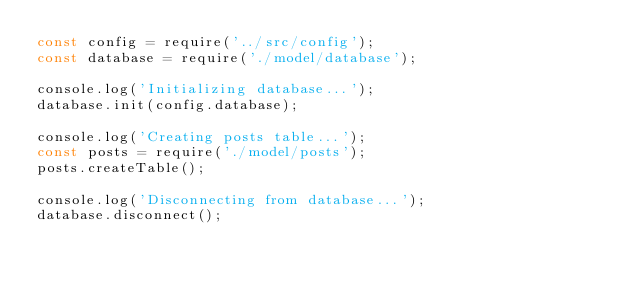Convert code to text. <code><loc_0><loc_0><loc_500><loc_500><_JavaScript_>const config = require('../src/config');
const database = require('./model/database');

console.log('Initializing database...');
database.init(config.database);

console.log('Creating posts table...');
const posts = require('./model/posts');
posts.createTable();

console.log('Disconnecting from database...');
database.disconnect();
</code> 